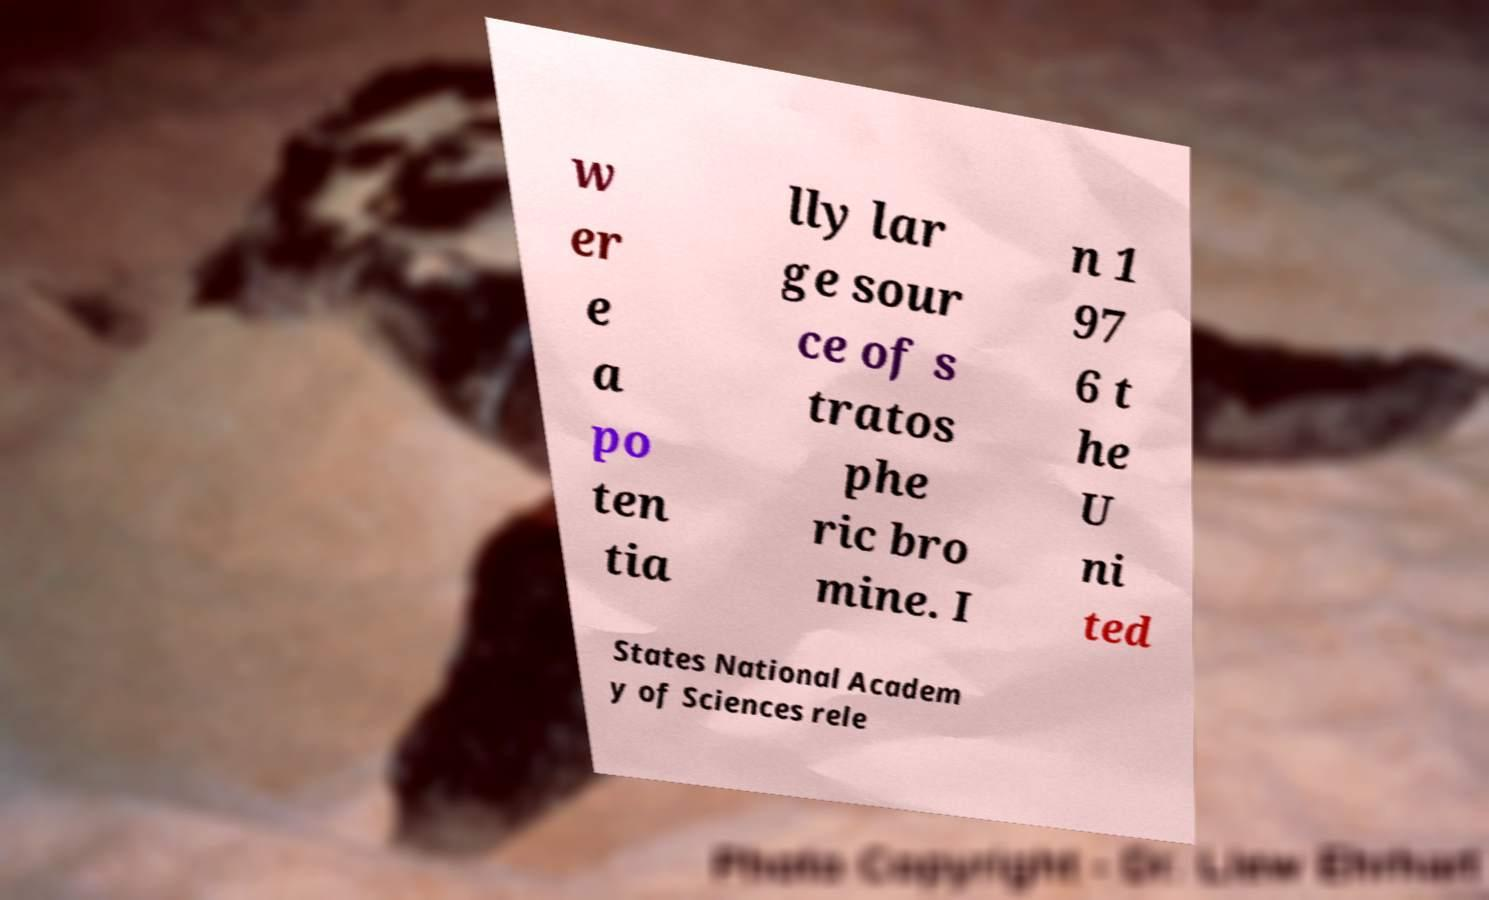Could you extract and type out the text from this image? w er e a po ten tia lly lar ge sour ce of s tratos phe ric bro mine. I n 1 97 6 t he U ni ted States National Academ y of Sciences rele 